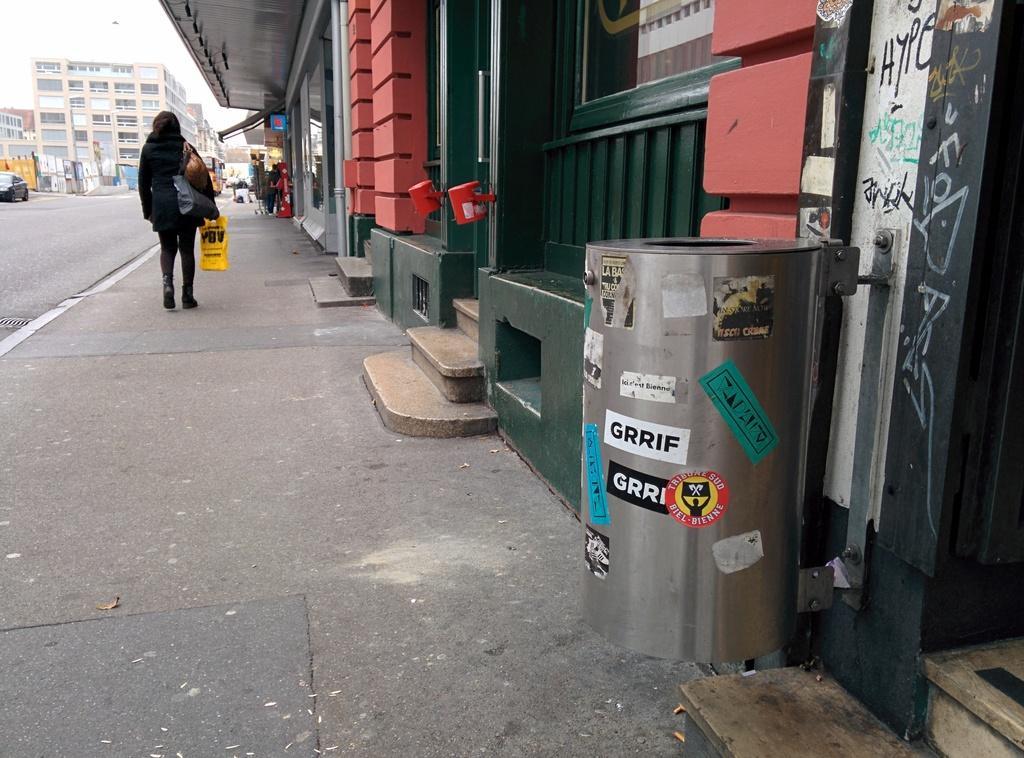Please provide a concise description of this image. In this image we can see buildings on the right side. And there is a bin. There is a lady holding bags and walking on the sidewalk. There are steps. Also there is a road. On the road there is a vehicle. In the background there is a building. 